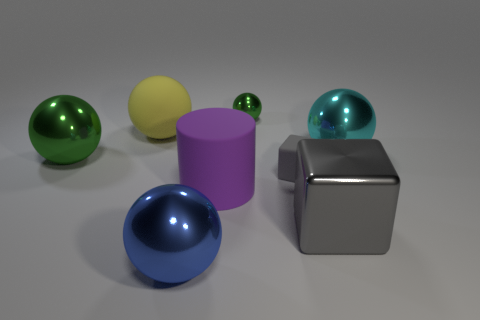Can you describe the textures of the objects? Certainly. The objects have different textures: the spheres have a reflective, glossy texture, while the cube and the cylinder have a mattified, slightly textured finish, showing the interplay of light and materials. 